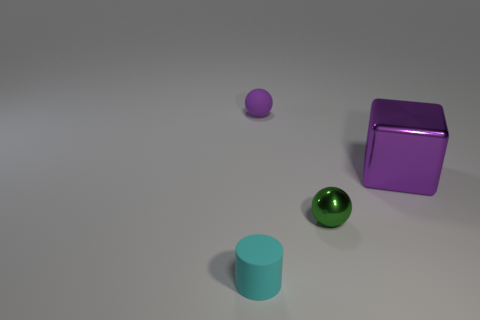Are there any blocks behind the tiny sphere that is to the right of the small rubber sphere?
Make the answer very short. Yes. What number of things are either small green metal blocks or purple rubber objects?
Keep it short and to the point. 1. What shape is the object that is in front of the purple cube and on the left side of the green shiny ball?
Your response must be concise. Cylinder. Is the material of the tiny sphere behind the purple metal cube the same as the green object?
Keep it short and to the point. No. How many things are large purple metallic things or purple shiny blocks that are on the right side of the tiny green metallic object?
Make the answer very short. 1. What is the color of the small object that is the same material as the big purple object?
Give a very brief answer. Green. How many balls have the same material as the large purple thing?
Your answer should be compact. 1. What number of large purple shiny cubes are there?
Offer a terse response. 1. Do the small ball in front of the metal block and the small rubber thing to the left of the small purple thing have the same color?
Your answer should be compact. No. There is a big metallic thing; how many metal objects are on the left side of it?
Give a very brief answer. 1. 